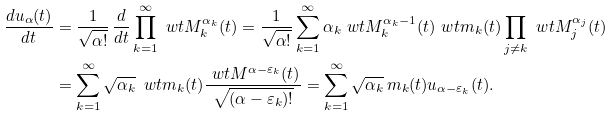Convert formula to latex. <formula><loc_0><loc_0><loc_500><loc_500>\frac { d u _ { \alpha } ( t ) } { d t } & = \frac { 1 } { \sqrt { \alpha ! } } \, \frac { d } { d t } \prod _ { k = 1 } ^ { \infty } \ w t { M } _ { k } ^ { \alpha _ { k } } ( t ) = \frac { 1 } { \sqrt { \alpha ! } } \sum _ { k = 1 } ^ { \infty } \alpha _ { k } \ w t { M } _ { k } ^ { \alpha _ { k } - 1 } ( t ) \ w t { m } _ { k } ( t ) \prod _ { j \not = k } \ w t { M } _ { j } ^ { \alpha _ { j } } ( t ) \\ & = \sum _ { k = 1 } ^ { \infty } \sqrt { \alpha _ { k } } \, \ w t { m } _ { k } ( t ) \frac { \ w t { M } ^ { \alpha - \varepsilon _ { k } } ( t ) } { \sqrt { ( \alpha - \varepsilon _ { k } ) ! } } = \sum _ { k = 1 } ^ { \infty } \sqrt { \alpha _ { k } } \, m _ { k } ( t ) u _ { \alpha - \varepsilon _ { k } } ( t ) .</formula> 